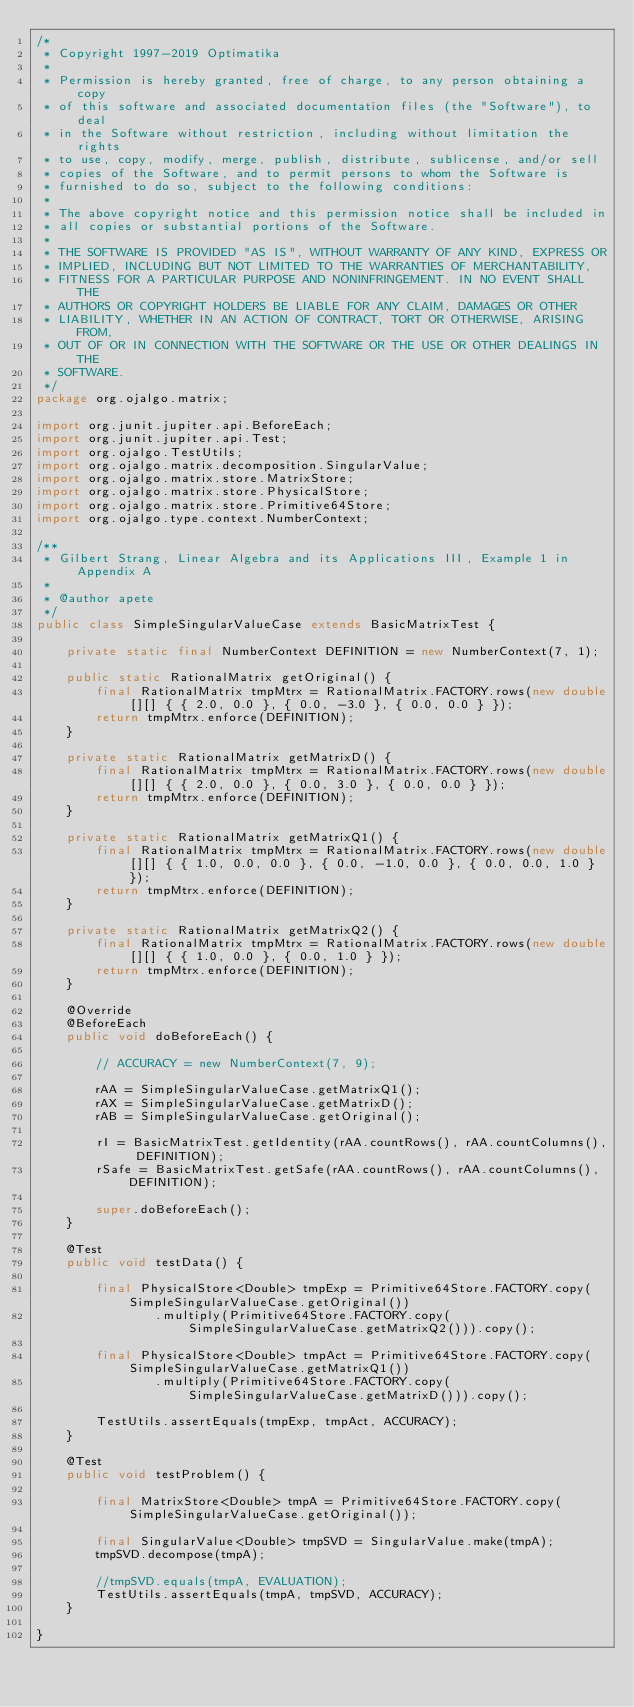<code> <loc_0><loc_0><loc_500><loc_500><_Java_>/*
 * Copyright 1997-2019 Optimatika
 *
 * Permission is hereby granted, free of charge, to any person obtaining a copy
 * of this software and associated documentation files (the "Software"), to deal
 * in the Software without restriction, including without limitation the rights
 * to use, copy, modify, merge, publish, distribute, sublicense, and/or sell
 * copies of the Software, and to permit persons to whom the Software is
 * furnished to do so, subject to the following conditions:
 *
 * The above copyright notice and this permission notice shall be included in
 * all copies or substantial portions of the Software.
 *
 * THE SOFTWARE IS PROVIDED "AS IS", WITHOUT WARRANTY OF ANY KIND, EXPRESS OR
 * IMPLIED, INCLUDING BUT NOT LIMITED TO THE WARRANTIES OF MERCHANTABILITY,
 * FITNESS FOR A PARTICULAR PURPOSE AND NONINFRINGEMENT. IN NO EVENT SHALL THE
 * AUTHORS OR COPYRIGHT HOLDERS BE LIABLE FOR ANY CLAIM, DAMAGES OR OTHER
 * LIABILITY, WHETHER IN AN ACTION OF CONTRACT, TORT OR OTHERWISE, ARISING FROM,
 * OUT OF OR IN CONNECTION WITH THE SOFTWARE OR THE USE OR OTHER DEALINGS IN THE
 * SOFTWARE.
 */
package org.ojalgo.matrix;

import org.junit.jupiter.api.BeforeEach;
import org.junit.jupiter.api.Test;
import org.ojalgo.TestUtils;
import org.ojalgo.matrix.decomposition.SingularValue;
import org.ojalgo.matrix.store.MatrixStore;
import org.ojalgo.matrix.store.PhysicalStore;
import org.ojalgo.matrix.store.Primitive64Store;
import org.ojalgo.type.context.NumberContext;

/**
 * Gilbert Strang, Linear Algebra and its Applications III, Example 1 in Appendix A
 *
 * @author apete
 */
public class SimpleSingularValueCase extends BasicMatrixTest {

    private static final NumberContext DEFINITION = new NumberContext(7, 1);

    public static RationalMatrix getOriginal() {
        final RationalMatrix tmpMtrx = RationalMatrix.FACTORY.rows(new double[][] { { 2.0, 0.0 }, { 0.0, -3.0 }, { 0.0, 0.0 } });
        return tmpMtrx.enforce(DEFINITION);
    }

    private static RationalMatrix getMatrixD() {
        final RationalMatrix tmpMtrx = RationalMatrix.FACTORY.rows(new double[][] { { 2.0, 0.0 }, { 0.0, 3.0 }, { 0.0, 0.0 } });
        return tmpMtrx.enforce(DEFINITION);
    }

    private static RationalMatrix getMatrixQ1() {
        final RationalMatrix tmpMtrx = RationalMatrix.FACTORY.rows(new double[][] { { 1.0, 0.0, 0.0 }, { 0.0, -1.0, 0.0 }, { 0.0, 0.0, 1.0 } });
        return tmpMtrx.enforce(DEFINITION);
    }

    private static RationalMatrix getMatrixQ2() {
        final RationalMatrix tmpMtrx = RationalMatrix.FACTORY.rows(new double[][] { { 1.0, 0.0 }, { 0.0, 1.0 } });
        return tmpMtrx.enforce(DEFINITION);
    }

    @Override
    @BeforeEach
    public void doBeforeEach() {

        // ACCURACY = new NumberContext(7, 9);

        rAA = SimpleSingularValueCase.getMatrixQ1();
        rAX = SimpleSingularValueCase.getMatrixD();
        rAB = SimpleSingularValueCase.getOriginal();

        rI = BasicMatrixTest.getIdentity(rAA.countRows(), rAA.countColumns(), DEFINITION);
        rSafe = BasicMatrixTest.getSafe(rAA.countRows(), rAA.countColumns(), DEFINITION);

        super.doBeforeEach();
    }

    @Test
    public void testData() {

        final PhysicalStore<Double> tmpExp = Primitive64Store.FACTORY.copy(SimpleSingularValueCase.getOriginal())
                .multiply(Primitive64Store.FACTORY.copy(SimpleSingularValueCase.getMatrixQ2())).copy();

        final PhysicalStore<Double> tmpAct = Primitive64Store.FACTORY.copy(SimpleSingularValueCase.getMatrixQ1())
                .multiply(Primitive64Store.FACTORY.copy(SimpleSingularValueCase.getMatrixD())).copy();

        TestUtils.assertEquals(tmpExp, tmpAct, ACCURACY);
    }

    @Test
    public void testProblem() {

        final MatrixStore<Double> tmpA = Primitive64Store.FACTORY.copy(SimpleSingularValueCase.getOriginal());

        final SingularValue<Double> tmpSVD = SingularValue.make(tmpA);
        tmpSVD.decompose(tmpA);

        //tmpSVD.equals(tmpA, EVALUATION);
        TestUtils.assertEquals(tmpA, tmpSVD, ACCURACY);
    }

}
</code> 